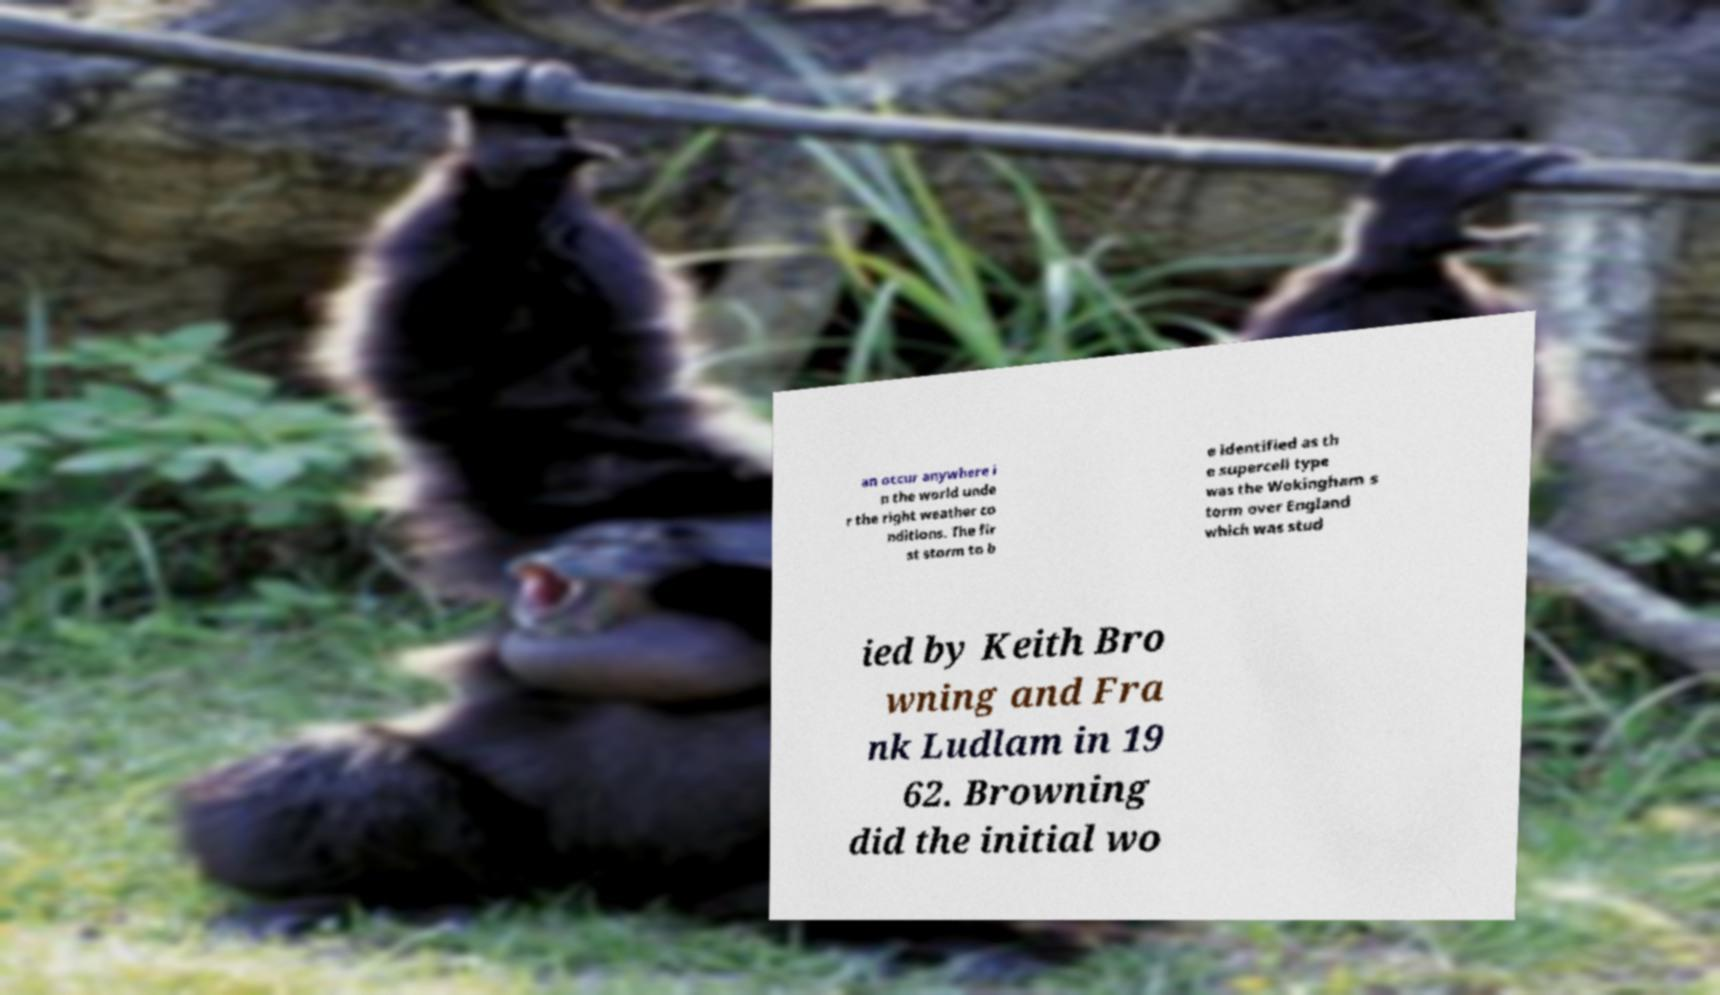Can you read and provide the text displayed in the image?This photo seems to have some interesting text. Can you extract and type it out for me? an occur anywhere i n the world unde r the right weather co nditions. The fir st storm to b e identified as th e supercell type was the Wokingham s torm over England which was stud ied by Keith Bro wning and Fra nk Ludlam in 19 62. Browning did the initial wo 